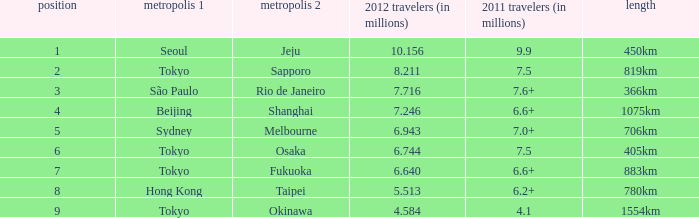In 2011, which urban center is mentioned first on the route that accommodated São Paulo. 